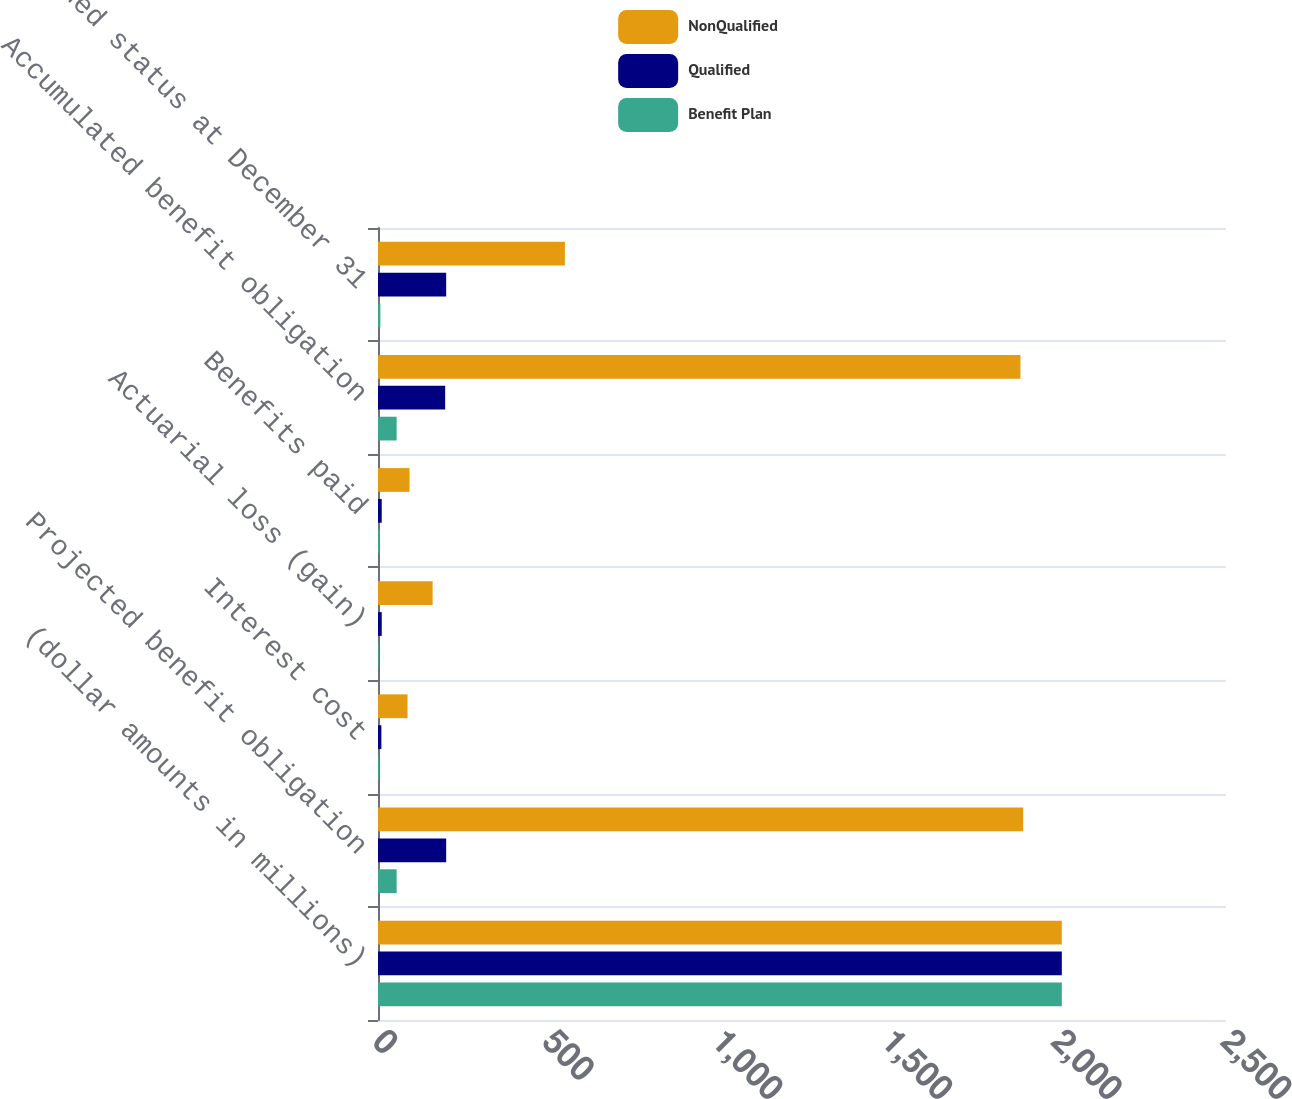Convert chart. <chart><loc_0><loc_0><loc_500><loc_500><stacked_bar_chart><ecel><fcel>(dollar amounts in millions)<fcel>Projected benefit obligation<fcel>Interest cost<fcel>Actuarial loss (gain)<fcel>Benefits paid<fcel>Accumulated benefit obligation<fcel>Funded status at December 31<nl><fcel>NonQualified<fcel>2016<fcel>1902<fcel>87<fcel>161<fcel>93<fcel>1894<fcel>551<nl><fcel>Qualified<fcel>2016<fcel>201<fcel>10<fcel>11<fcel>11<fcel>198<fcel>201<nl><fcel>Benefit Plan<fcel>2016<fcel>55<fcel>3<fcel>2<fcel>5<fcel>55<fcel>7<nl></chart> 